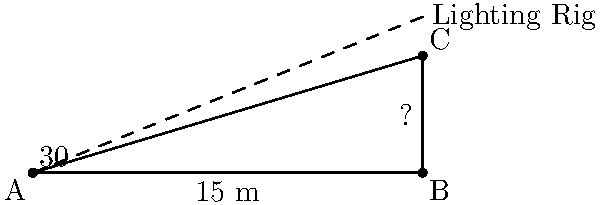As a hair stylist on the Grey's Anatomy set, you're curious about the height of a new lighting rig. Using a clinometer, you measure the angle of elevation to the top of the rig to be 30°. If you're standing 15 meters away from the base of the rig, how tall is it? Let's approach this step-by-step:

1) We can model this situation as a right triangle, where:
   - The base of the triangle is the distance from you to the rig (15 m)
   - The height of the triangle is the height of the rig (what we're solving for)
   - The angle between the base and the hypotenuse is 30°

2) In this right triangle, we know:
   - The adjacent side (base) = 15 m
   - The angle = 30°
   - We need to find the opposite side (height)

3) This scenario calls for the tangent ratio:

   $\tan \theta = \frac{\text{opposite}}{\text{adjacent}}$

4) Plugging in our known values:

   $\tan 30° = \frac{\text{height}}{15}$

5) We can solve this equation for height:

   $\text{height} = 15 \times \tan 30°$

6) $\tan 30° = \frac{1}{\sqrt{3}} \approx 0.577$

7) Therefore:

   $\text{height} = 15 \times 0.577 = 8.66$ m

8) Rounding to the nearest centimeter:

   $\text{height} \approx 8.66$ m
Answer: 8.66 m 